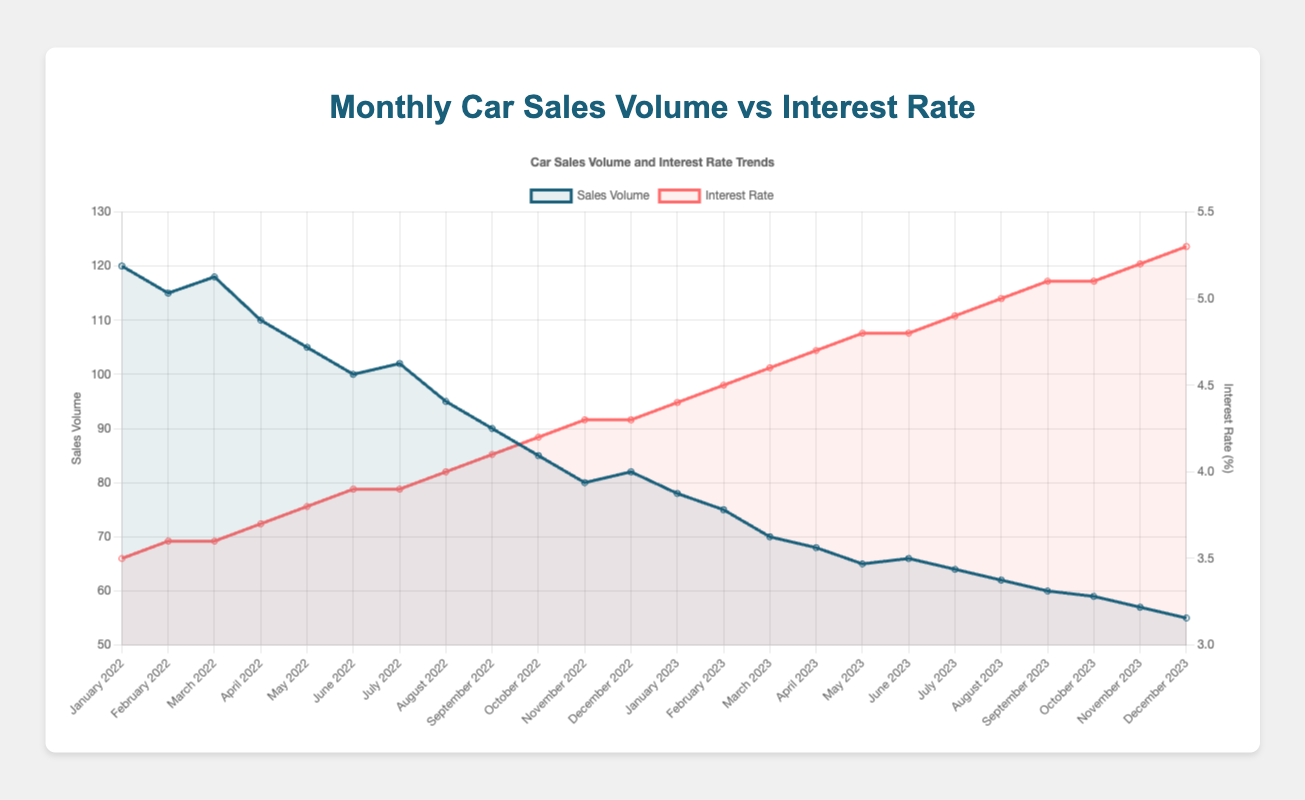What's the trend in car sales volume from January 2022 to December 2023? To answer this question, observe the overall trajectory of the sales volume line. It starts at 120 units in January 2022 and shows a general downward trend, ending at 55 units in December 2023. This indicates a consistent decrease in sales volume over the period.
Answer: Decreasing trend Which month had the lowest sales volume, and what was the interest rate then? Check the sales volume line to find the lowest point. In December 2023, the sales volume was at its lowest, 55 units. Cross-reference this with the interest rate at the same point, which was 5.3%.
Answer: December 2023, 5.3% How did sales volume change when interest rates moved from 3.5% to 5.3%? Compare the sales volumes corresponding to these interest rates. At 3.5% (January 2022), the sales volume was 120 units, and at 5.3% (December 2023), it dropped to 55 units. Calculate the difference to find the change: 120 - 55 = 65 units.
Answer: Decreased by 65 units In which months did the interest rate remain unchanged? Examine the interest rate line to identify flat sections. The interest rate stayed at 3.6% from February to March 2022 (2 months), at 3.9% from June to July 2022 (2 months), at 4.3% from November to December 2022 (2 months), and at 4.8% from May to June 2023 (2 months).
Answer: February to March 2022, June to July 2022, November to December 2022, May to June 2023 Between January 2022 and December 2023, what is the average interest rate? Sum all the monthly interest rates and divide by the number of months. The interest rates are: (3.5 + 3.6 + 3.6 + 3.7 + 3.8 + 3.9 + 3.9 + 4.0 + 4.1 + 4.2 + 4.3 + 4.3 + 4.4 + 4.5 + 4.6 + 4.7 + 4.8 + 4.8 + 4.9 + 5.0 + 5.1 + 5.1 + 5.2 + 5.3). This sums to 103.6, and there are 24 months, so 103.6/24 ≈ 4.32%.
Answer: 4.32% Was there any month where the sales volume increased despite an increase in interest rates? Scan for sections where the sales volume line increases while the interest rate also increases. From November to December 2022, the sales volume increased from 80 to 82 units even though the interest rate increased from 4.3% to 4.3% (a slight increase).
Answer: November to December 2022 Compare the sales volume for July 2022 and July 2023. Which month had a higher sales volume and by how much? Check the sales volume values for July 2022 and July 2023. July 2022 had 102 units, and July 2023 had 64 units. The difference is 102 - 64 = 38 units.
Answer: July 2022 by 38 units What was the general trend of interest rates from January 2022 to December 2023? Observe the interest rate line, which generally moves upward. It starts at 3.5% in January 2022 and ends at 5.3% in December 2023, indicating a clear increasing trend over the specified period.
Answer: Increasing trend 